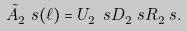<formula> <loc_0><loc_0><loc_500><loc_500>\tilde { A } _ { 2 } ^ { \ } s ( \ell ) = U _ { 2 } ^ { \ } s D _ { 2 } ^ { \ } s R _ { 2 } ^ { \ } s .</formula> 